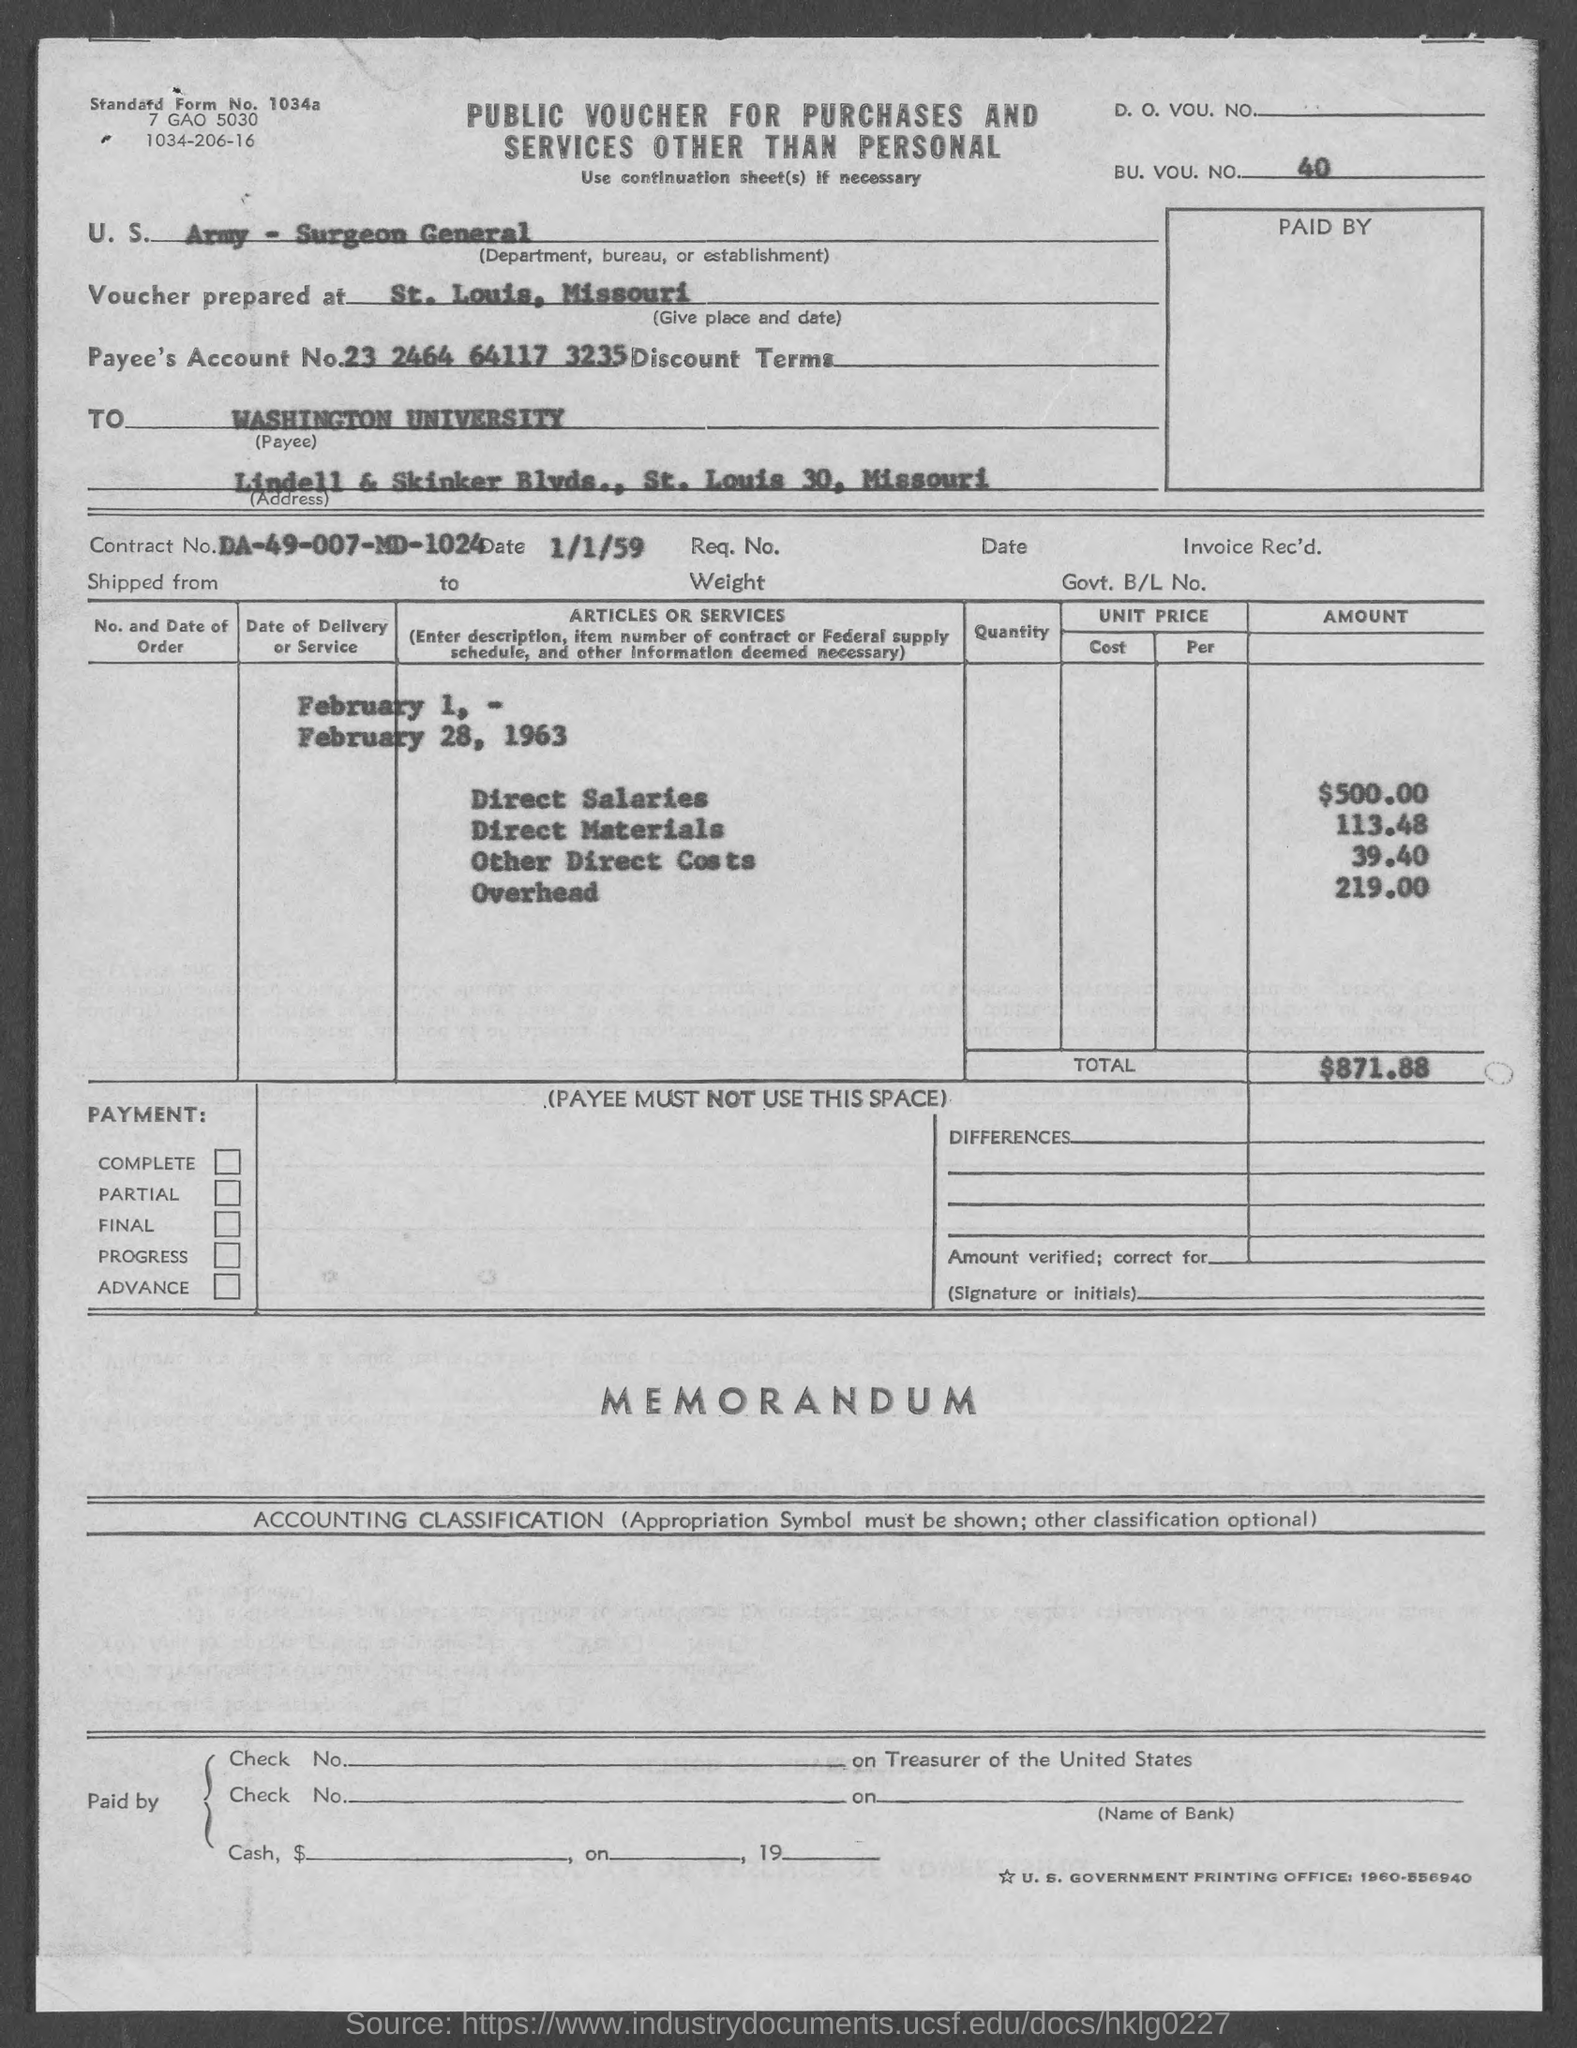What type of voucher is given here?
Keep it short and to the point. PUBLIC VOUCHER FOR PURCHASES AND SERVICES OTHER THAN PERSONAL. What is the BU. VOU. NO. mentioned in the voucher?
Your answer should be very brief. 40. Where is the voucher prepared at?
Give a very brief answer. St. Louis, Missouri. What is the Contract No. given in the voucher?
Keep it short and to the point. DA-49-007-MD-1024. What is the Payee's Account No. given in the voucher?
Give a very brief answer. 23 2464 64117 3235. What is the direct salaries cost mentioned in the voucher?
Provide a succinct answer. 500.00. What is the total amount mentioned in the voucher?
Make the answer very short. $871.88. 